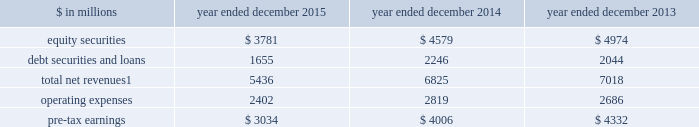The goldman sachs group , inc .
And subsidiaries management 2019s discussion and analysis investing & lending investing & lending includes our investing activities and the origination of loans to provide financing to clients .
These investments and loans are typically longer-term in nature .
We make investments , some of which are consolidated , directly and indirectly through funds and separate accounts that we manage , in debt securities and loans , public and private equity securities , and real estate entities .
The table below presents the operating results of our investing & lending segment. .
Net revenues related to our consolidated investments , previously reported in other net revenues within investing & lending , are now reported in equity securities and debt securities and loans , as results from these activities ( $ 391 million for 2015 ) are no longer significant principally due to the sale of metro in the fourth quarter of 2014 .
Reclassifications have been made to previously reported amounts to conform to the current presentation .
2015 versus 2014 .
Net revenues in investing & lending were $ 5.44 billion for 2015 , 20% ( 20 % ) lower than 2014 .
This decrease was primarily due to lower net revenues from investments in equities , principally reflecting the sale of metro in the fourth quarter of 2014 and lower net gains from investments in private equities , driven by corporate performance .
In addition , net revenues in debt securities and loans were significantly lower , reflecting lower net gains from investments .
Although net revenues in investing & lending for 2015 benefited from favorable company-specific events , including sales , initial public offerings and financings , a decline in global equity prices and widening high-yield credit spreads during the second half of the year impacted results .
Concern about the outlook for the global economy continues to be a meaningful consideration for the global marketplace .
If equity markets continue to decline or credit spreads widen further , net revenues in investing & lending would likely continue to be negatively impacted .
Operating expenses were $ 2.40 billion for 2015 , 15% ( 15 % ) lower than 2014 , due to lower depreciation and amortization expenses , primarily reflecting lower impairment charges related to consolidated investments , and a reduction in expenses related to the sale of metro in the fourth quarter of 2014 .
Pre-tax earnings were $ 3.03 billion in 2015 , 24% ( 24 % ) lower than 2014 .
2014 versus 2013 .
Net revenues in investing & lending were $ 6.83 billion for 2014 , 3% ( 3 % ) lower than 2013 .
Net revenues from investments in equity securities were lower due to a significant decrease in net gains from investments in public equities , as movements in global equity prices during 2014 were less favorable compared with 2013 , as well as significantly lower net revenues related to our consolidated investments , reflecting a decrease in operating revenues from commodities-related consolidated investments .
These decreases were partially offset by an increase in net gains from investments in private equities , primarily driven by company-specific events .
Net revenues from debt securities and loans were higher than 2013 , reflecting a significant increase in net interest income , primarily driven by increased lending , and a slight increase in net gains , primarily due to sales of certain investments during 2014 .
During 2014 , net revenues in investing & lending generally reflected favorable company-specific events , including initial public offerings and financings , and strong corporate performance , as well as net gains from sales of certain investments .
Operating expenses were $ 2.82 billion for 2014 , 5% ( 5 % ) higher than 2013 , reflecting higher compensation and benefits expenses , partially offset by lower expenses related to consolidated investments .
Pre-tax earnings were $ 4.01 billion in 2014 , 8% ( 8 % ) lower than 2013 .
64 goldman sachs 2015 form 10-k .
In millions for 2015 , 2014 , and 2013 , what were the largest amount of debt securities and loans? 
Computations: table_max(debt securities and loans, none)
Answer: 2246.0. The goldman sachs group , inc .
And subsidiaries management 2019s discussion and analysis investing & lending investing & lending includes our investing activities and the origination of loans to provide financing to clients .
These investments and loans are typically longer-term in nature .
We make investments , some of which are consolidated , directly and indirectly through funds and separate accounts that we manage , in debt securities and loans , public and private equity securities , and real estate entities .
The table below presents the operating results of our investing & lending segment. .
Net revenues related to our consolidated investments , previously reported in other net revenues within investing & lending , are now reported in equity securities and debt securities and loans , as results from these activities ( $ 391 million for 2015 ) are no longer significant principally due to the sale of metro in the fourth quarter of 2014 .
Reclassifications have been made to previously reported amounts to conform to the current presentation .
2015 versus 2014 .
Net revenues in investing & lending were $ 5.44 billion for 2015 , 20% ( 20 % ) lower than 2014 .
This decrease was primarily due to lower net revenues from investments in equities , principally reflecting the sale of metro in the fourth quarter of 2014 and lower net gains from investments in private equities , driven by corporate performance .
In addition , net revenues in debt securities and loans were significantly lower , reflecting lower net gains from investments .
Although net revenues in investing & lending for 2015 benefited from favorable company-specific events , including sales , initial public offerings and financings , a decline in global equity prices and widening high-yield credit spreads during the second half of the year impacted results .
Concern about the outlook for the global economy continues to be a meaningful consideration for the global marketplace .
If equity markets continue to decline or credit spreads widen further , net revenues in investing & lending would likely continue to be negatively impacted .
Operating expenses were $ 2.40 billion for 2015 , 15% ( 15 % ) lower than 2014 , due to lower depreciation and amortization expenses , primarily reflecting lower impairment charges related to consolidated investments , and a reduction in expenses related to the sale of metro in the fourth quarter of 2014 .
Pre-tax earnings were $ 3.03 billion in 2015 , 24% ( 24 % ) lower than 2014 .
2014 versus 2013 .
Net revenues in investing & lending were $ 6.83 billion for 2014 , 3% ( 3 % ) lower than 2013 .
Net revenues from investments in equity securities were lower due to a significant decrease in net gains from investments in public equities , as movements in global equity prices during 2014 were less favorable compared with 2013 , as well as significantly lower net revenues related to our consolidated investments , reflecting a decrease in operating revenues from commodities-related consolidated investments .
These decreases were partially offset by an increase in net gains from investments in private equities , primarily driven by company-specific events .
Net revenues from debt securities and loans were higher than 2013 , reflecting a significant increase in net interest income , primarily driven by increased lending , and a slight increase in net gains , primarily due to sales of certain investments during 2014 .
During 2014 , net revenues in investing & lending generally reflected favorable company-specific events , including initial public offerings and financings , and strong corporate performance , as well as net gains from sales of certain investments .
Operating expenses were $ 2.82 billion for 2014 , 5% ( 5 % ) higher than 2013 , reflecting higher compensation and benefits expenses , partially offset by lower expenses related to consolidated investments .
Pre-tax earnings were $ 4.01 billion in 2014 , 8% ( 8 % ) lower than 2013 .
64 goldman sachs 2015 form 10-k .
In millions for 2015 , 2014 , and 2013 , what was the lowest equity securities?\\n\\n? 
Computations: table_min(equity securities, none)
Answer: 3781.0. 